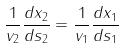<formula> <loc_0><loc_0><loc_500><loc_500>\frac { 1 } { v _ { 2 } } \frac { d x _ { 2 } } { d s _ { 2 } } = \frac { 1 } { v _ { 1 } } \frac { d x _ { 1 } } { d s _ { 1 } }</formula> 